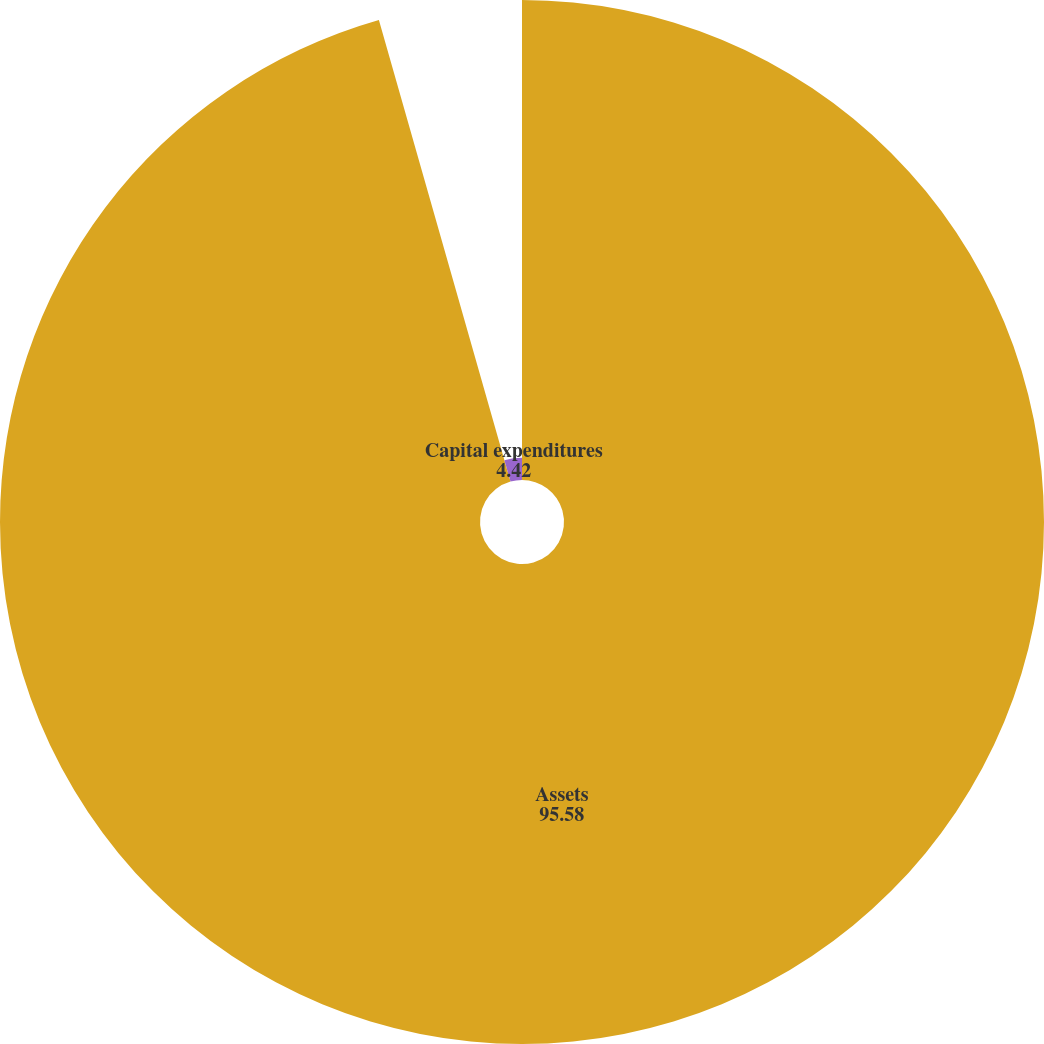Convert chart. <chart><loc_0><loc_0><loc_500><loc_500><pie_chart><fcel>Assets<fcel>Capital expenditures<nl><fcel>95.58%<fcel>4.42%<nl></chart> 